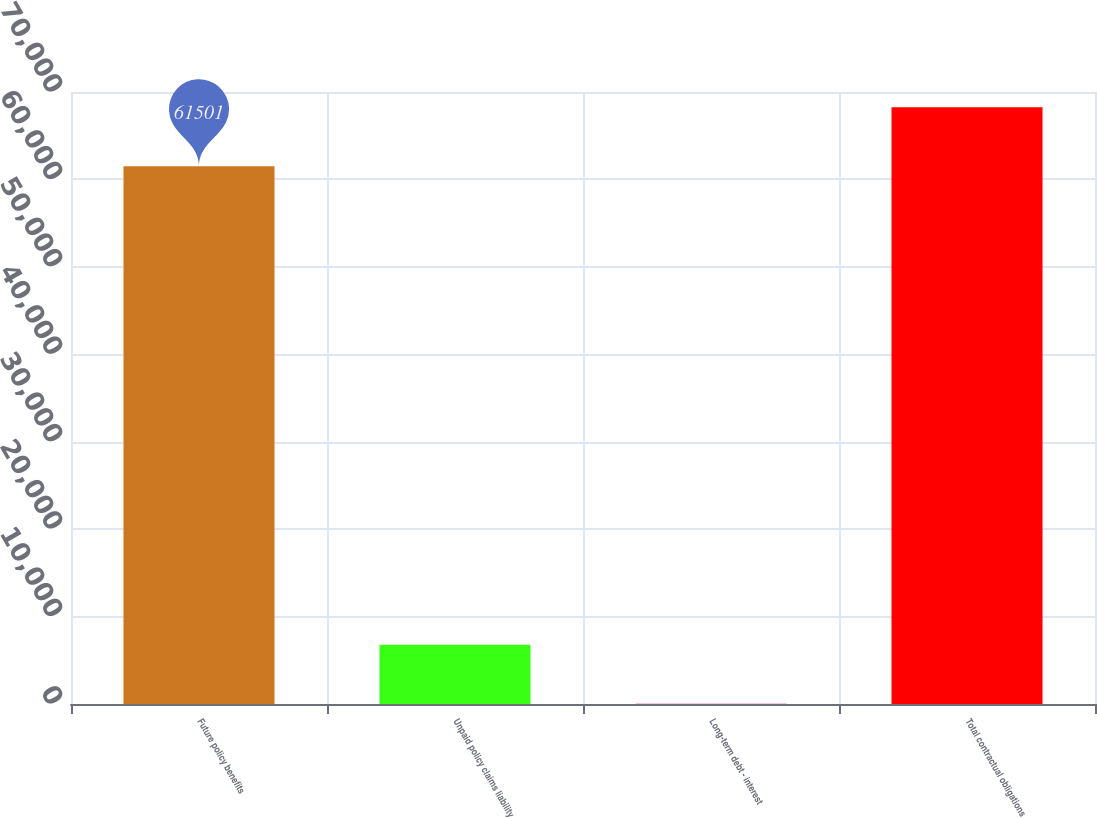<chart> <loc_0><loc_0><loc_500><loc_500><bar_chart><fcel>Future policy benefits<fcel>Unpaid policy claims liability<fcel>Long-term debt - interest<fcel>Total contractual obligations<nl><fcel>61501<fcel>6765.8<fcel>16<fcel>68250.8<nl></chart> 